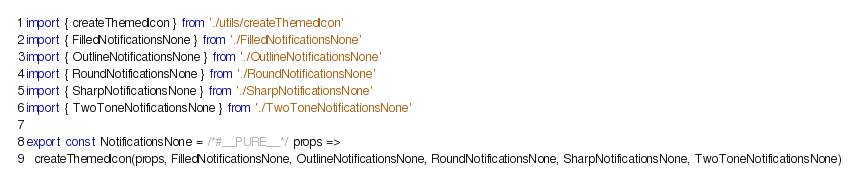Convert code to text. <code><loc_0><loc_0><loc_500><loc_500><_JavaScript_>import { createThemedIcon } from './utils/createThemedIcon'
import { FilledNotificationsNone } from './FilledNotificationsNone'
import { OutlineNotificationsNone } from './OutlineNotificationsNone'
import { RoundNotificationsNone } from './RoundNotificationsNone'
import { SharpNotificationsNone } from './SharpNotificationsNone'
import { TwoToneNotificationsNone } from './TwoToneNotificationsNone'

export const NotificationsNone = /*#__PURE__*/ props =>
  createThemedIcon(props, FilledNotificationsNone, OutlineNotificationsNone, RoundNotificationsNone, SharpNotificationsNone, TwoToneNotificationsNone)
</code> 